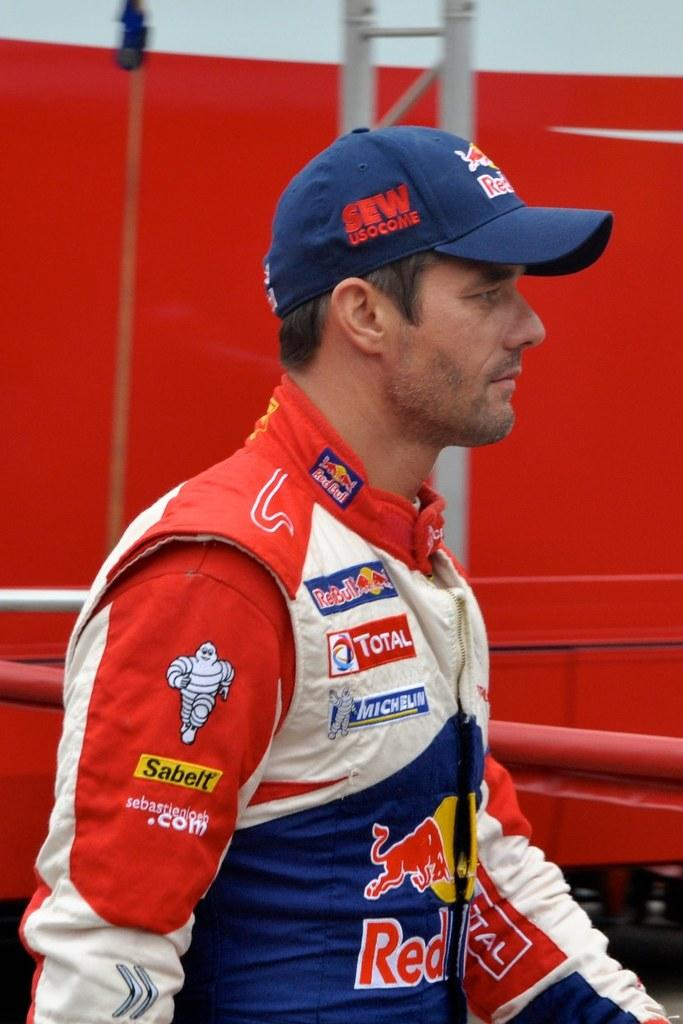<image>
Present a compact description of the photo's key features. Man with a fire suit on that has Sabelt on his right arm in a yellow rectangular patch. 